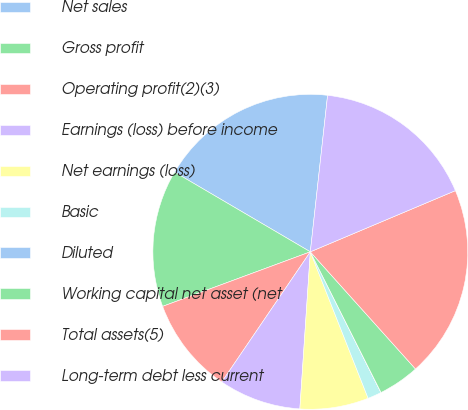Convert chart to OTSL. <chart><loc_0><loc_0><loc_500><loc_500><pie_chart><fcel>Net sales<fcel>Gross profit<fcel>Operating profit(2)(3)<fcel>Earnings (loss) before income<fcel>Net earnings (loss)<fcel>Basic<fcel>Diluted<fcel>Working capital net asset (net<fcel>Total assets(5)<fcel>Long-term debt less current<nl><fcel>18.3%<fcel>14.08%<fcel>9.86%<fcel>8.45%<fcel>7.04%<fcel>1.42%<fcel>0.01%<fcel>4.23%<fcel>19.71%<fcel>16.9%<nl></chart> 